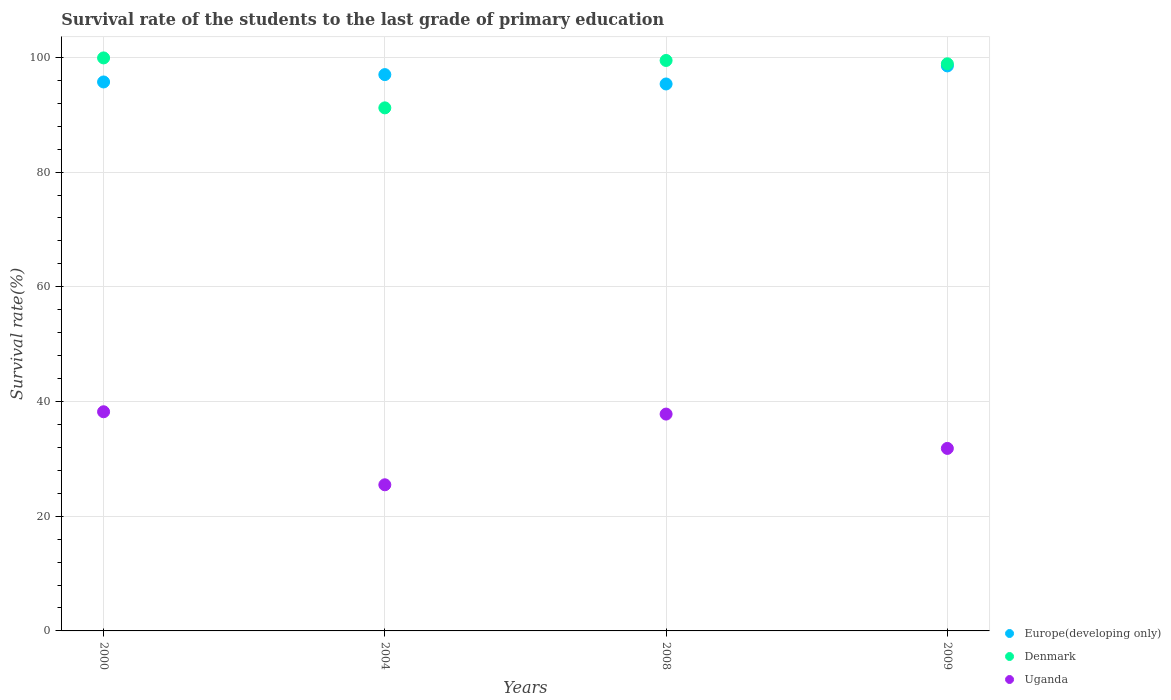How many different coloured dotlines are there?
Offer a terse response. 3. What is the survival rate of the students in Europe(developing only) in 2000?
Provide a short and direct response. 95.72. Across all years, what is the maximum survival rate of the students in Denmark?
Your answer should be very brief. 99.91. Across all years, what is the minimum survival rate of the students in Uganda?
Your answer should be very brief. 25.48. In which year was the survival rate of the students in Denmark maximum?
Offer a very short reply. 2000. In which year was the survival rate of the students in Europe(developing only) minimum?
Ensure brevity in your answer.  2008. What is the total survival rate of the students in Europe(developing only) in the graph?
Provide a succinct answer. 386.61. What is the difference between the survival rate of the students in Denmark in 2004 and that in 2009?
Your answer should be compact. -7.68. What is the difference between the survival rate of the students in Uganda in 2004 and the survival rate of the students in Denmark in 2000?
Make the answer very short. -74.43. What is the average survival rate of the students in Europe(developing only) per year?
Keep it short and to the point. 96.65. In the year 2004, what is the difference between the survival rate of the students in Europe(developing only) and survival rate of the students in Denmark?
Make the answer very short. 5.8. What is the ratio of the survival rate of the students in Uganda in 2004 to that in 2009?
Offer a very short reply. 0.8. Is the survival rate of the students in Uganda in 2004 less than that in 2009?
Provide a short and direct response. Yes. Is the difference between the survival rate of the students in Europe(developing only) in 2000 and 2009 greater than the difference between the survival rate of the students in Denmark in 2000 and 2009?
Your answer should be compact. No. What is the difference between the highest and the second highest survival rate of the students in Uganda?
Your response must be concise. 0.41. What is the difference between the highest and the lowest survival rate of the students in Denmark?
Your answer should be compact. 8.71. Is the sum of the survival rate of the students in Denmark in 2000 and 2008 greater than the maximum survival rate of the students in Uganda across all years?
Provide a succinct answer. Yes. Does the survival rate of the students in Europe(developing only) monotonically increase over the years?
Provide a short and direct response. No. Is the survival rate of the students in Europe(developing only) strictly less than the survival rate of the students in Denmark over the years?
Provide a succinct answer. No. How many years are there in the graph?
Your answer should be very brief. 4. Are the values on the major ticks of Y-axis written in scientific E-notation?
Your response must be concise. No. Does the graph contain any zero values?
Provide a succinct answer. No. Does the graph contain grids?
Offer a very short reply. Yes. How many legend labels are there?
Make the answer very short. 3. What is the title of the graph?
Give a very brief answer. Survival rate of the students to the last grade of primary education. What is the label or title of the X-axis?
Provide a succinct answer. Years. What is the label or title of the Y-axis?
Give a very brief answer. Survival rate(%). What is the Survival rate(%) in Europe(developing only) in 2000?
Your answer should be compact. 95.72. What is the Survival rate(%) in Denmark in 2000?
Keep it short and to the point. 99.91. What is the Survival rate(%) in Uganda in 2000?
Your response must be concise. 38.21. What is the Survival rate(%) of Europe(developing only) in 2004?
Provide a succinct answer. 97. What is the Survival rate(%) of Denmark in 2004?
Keep it short and to the point. 91.2. What is the Survival rate(%) in Uganda in 2004?
Ensure brevity in your answer.  25.48. What is the Survival rate(%) in Europe(developing only) in 2008?
Your answer should be compact. 95.37. What is the Survival rate(%) in Denmark in 2008?
Offer a very short reply. 99.47. What is the Survival rate(%) in Uganda in 2008?
Your answer should be very brief. 37.81. What is the Survival rate(%) of Europe(developing only) in 2009?
Offer a terse response. 98.52. What is the Survival rate(%) of Denmark in 2009?
Give a very brief answer. 98.89. What is the Survival rate(%) in Uganda in 2009?
Your response must be concise. 31.82. Across all years, what is the maximum Survival rate(%) of Europe(developing only)?
Offer a terse response. 98.52. Across all years, what is the maximum Survival rate(%) of Denmark?
Offer a terse response. 99.91. Across all years, what is the maximum Survival rate(%) in Uganda?
Your answer should be compact. 38.21. Across all years, what is the minimum Survival rate(%) of Europe(developing only)?
Provide a succinct answer. 95.37. Across all years, what is the minimum Survival rate(%) of Denmark?
Offer a very short reply. 91.2. Across all years, what is the minimum Survival rate(%) in Uganda?
Your answer should be very brief. 25.48. What is the total Survival rate(%) of Europe(developing only) in the graph?
Offer a very short reply. 386.61. What is the total Survival rate(%) in Denmark in the graph?
Your answer should be compact. 389.47. What is the total Survival rate(%) of Uganda in the graph?
Offer a very short reply. 133.33. What is the difference between the Survival rate(%) in Europe(developing only) in 2000 and that in 2004?
Give a very brief answer. -1.28. What is the difference between the Survival rate(%) of Denmark in 2000 and that in 2004?
Provide a short and direct response. 8.71. What is the difference between the Survival rate(%) in Uganda in 2000 and that in 2004?
Make the answer very short. 12.73. What is the difference between the Survival rate(%) of Europe(developing only) in 2000 and that in 2008?
Give a very brief answer. 0.35. What is the difference between the Survival rate(%) of Denmark in 2000 and that in 2008?
Your answer should be compact. 0.44. What is the difference between the Survival rate(%) in Uganda in 2000 and that in 2008?
Provide a succinct answer. 0.41. What is the difference between the Survival rate(%) of Europe(developing only) in 2000 and that in 2009?
Ensure brevity in your answer.  -2.8. What is the difference between the Survival rate(%) in Denmark in 2000 and that in 2009?
Give a very brief answer. 1.03. What is the difference between the Survival rate(%) in Uganda in 2000 and that in 2009?
Your answer should be very brief. 6.39. What is the difference between the Survival rate(%) in Europe(developing only) in 2004 and that in 2008?
Provide a short and direct response. 1.63. What is the difference between the Survival rate(%) in Denmark in 2004 and that in 2008?
Your answer should be compact. -8.26. What is the difference between the Survival rate(%) of Uganda in 2004 and that in 2008?
Provide a succinct answer. -12.33. What is the difference between the Survival rate(%) in Europe(developing only) in 2004 and that in 2009?
Your response must be concise. -1.52. What is the difference between the Survival rate(%) in Denmark in 2004 and that in 2009?
Your answer should be very brief. -7.68. What is the difference between the Survival rate(%) in Uganda in 2004 and that in 2009?
Ensure brevity in your answer.  -6.34. What is the difference between the Survival rate(%) in Europe(developing only) in 2008 and that in 2009?
Keep it short and to the point. -3.15. What is the difference between the Survival rate(%) of Denmark in 2008 and that in 2009?
Provide a succinct answer. 0.58. What is the difference between the Survival rate(%) of Uganda in 2008 and that in 2009?
Offer a terse response. 5.98. What is the difference between the Survival rate(%) in Europe(developing only) in 2000 and the Survival rate(%) in Denmark in 2004?
Make the answer very short. 4.52. What is the difference between the Survival rate(%) of Europe(developing only) in 2000 and the Survival rate(%) of Uganda in 2004?
Keep it short and to the point. 70.24. What is the difference between the Survival rate(%) of Denmark in 2000 and the Survival rate(%) of Uganda in 2004?
Offer a very short reply. 74.43. What is the difference between the Survival rate(%) of Europe(developing only) in 2000 and the Survival rate(%) of Denmark in 2008?
Offer a very short reply. -3.75. What is the difference between the Survival rate(%) of Europe(developing only) in 2000 and the Survival rate(%) of Uganda in 2008?
Offer a very short reply. 57.91. What is the difference between the Survival rate(%) of Denmark in 2000 and the Survival rate(%) of Uganda in 2008?
Your answer should be compact. 62.1. What is the difference between the Survival rate(%) of Europe(developing only) in 2000 and the Survival rate(%) of Denmark in 2009?
Keep it short and to the point. -3.17. What is the difference between the Survival rate(%) of Europe(developing only) in 2000 and the Survival rate(%) of Uganda in 2009?
Your response must be concise. 63.9. What is the difference between the Survival rate(%) in Denmark in 2000 and the Survival rate(%) in Uganda in 2009?
Give a very brief answer. 68.09. What is the difference between the Survival rate(%) in Europe(developing only) in 2004 and the Survival rate(%) in Denmark in 2008?
Provide a succinct answer. -2.47. What is the difference between the Survival rate(%) in Europe(developing only) in 2004 and the Survival rate(%) in Uganda in 2008?
Make the answer very short. 59.19. What is the difference between the Survival rate(%) of Denmark in 2004 and the Survival rate(%) of Uganda in 2008?
Provide a succinct answer. 53.39. What is the difference between the Survival rate(%) in Europe(developing only) in 2004 and the Survival rate(%) in Denmark in 2009?
Your response must be concise. -1.88. What is the difference between the Survival rate(%) of Europe(developing only) in 2004 and the Survival rate(%) of Uganda in 2009?
Provide a succinct answer. 65.18. What is the difference between the Survival rate(%) in Denmark in 2004 and the Survival rate(%) in Uganda in 2009?
Offer a very short reply. 59.38. What is the difference between the Survival rate(%) in Europe(developing only) in 2008 and the Survival rate(%) in Denmark in 2009?
Keep it short and to the point. -3.52. What is the difference between the Survival rate(%) in Europe(developing only) in 2008 and the Survival rate(%) in Uganda in 2009?
Your answer should be very brief. 63.54. What is the difference between the Survival rate(%) in Denmark in 2008 and the Survival rate(%) in Uganda in 2009?
Give a very brief answer. 67.64. What is the average Survival rate(%) of Europe(developing only) per year?
Your answer should be very brief. 96.65. What is the average Survival rate(%) in Denmark per year?
Make the answer very short. 97.37. What is the average Survival rate(%) in Uganda per year?
Your response must be concise. 33.33. In the year 2000, what is the difference between the Survival rate(%) in Europe(developing only) and Survival rate(%) in Denmark?
Ensure brevity in your answer.  -4.19. In the year 2000, what is the difference between the Survival rate(%) of Europe(developing only) and Survival rate(%) of Uganda?
Your answer should be compact. 57.51. In the year 2000, what is the difference between the Survival rate(%) of Denmark and Survival rate(%) of Uganda?
Provide a short and direct response. 61.7. In the year 2004, what is the difference between the Survival rate(%) of Europe(developing only) and Survival rate(%) of Denmark?
Provide a succinct answer. 5.8. In the year 2004, what is the difference between the Survival rate(%) in Europe(developing only) and Survival rate(%) in Uganda?
Provide a succinct answer. 71.52. In the year 2004, what is the difference between the Survival rate(%) in Denmark and Survival rate(%) in Uganda?
Your answer should be compact. 65.72. In the year 2008, what is the difference between the Survival rate(%) of Europe(developing only) and Survival rate(%) of Denmark?
Your response must be concise. -4.1. In the year 2008, what is the difference between the Survival rate(%) in Europe(developing only) and Survival rate(%) in Uganda?
Give a very brief answer. 57.56. In the year 2008, what is the difference between the Survival rate(%) of Denmark and Survival rate(%) of Uganda?
Provide a short and direct response. 61.66. In the year 2009, what is the difference between the Survival rate(%) of Europe(developing only) and Survival rate(%) of Denmark?
Your response must be concise. -0.37. In the year 2009, what is the difference between the Survival rate(%) of Europe(developing only) and Survival rate(%) of Uganda?
Your answer should be very brief. 66.7. In the year 2009, what is the difference between the Survival rate(%) of Denmark and Survival rate(%) of Uganda?
Make the answer very short. 67.06. What is the ratio of the Survival rate(%) in Europe(developing only) in 2000 to that in 2004?
Make the answer very short. 0.99. What is the ratio of the Survival rate(%) of Denmark in 2000 to that in 2004?
Make the answer very short. 1.1. What is the ratio of the Survival rate(%) in Uganda in 2000 to that in 2004?
Give a very brief answer. 1.5. What is the ratio of the Survival rate(%) of Europe(developing only) in 2000 to that in 2008?
Your answer should be very brief. 1. What is the ratio of the Survival rate(%) in Denmark in 2000 to that in 2008?
Keep it short and to the point. 1. What is the ratio of the Survival rate(%) in Uganda in 2000 to that in 2008?
Provide a short and direct response. 1.01. What is the ratio of the Survival rate(%) of Europe(developing only) in 2000 to that in 2009?
Make the answer very short. 0.97. What is the ratio of the Survival rate(%) in Denmark in 2000 to that in 2009?
Keep it short and to the point. 1.01. What is the ratio of the Survival rate(%) in Uganda in 2000 to that in 2009?
Keep it short and to the point. 1.2. What is the ratio of the Survival rate(%) of Europe(developing only) in 2004 to that in 2008?
Your response must be concise. 1.02. What is the ratio of the Survival rate(%) of Denmark in 2004 to that in 2008?
Offer a very short reply. 0.92. What is the ratio of the Survival rate(%) of Uganda in 2004 to that in 2008?
Your response must be concise. 0.67. What is the ratio of the Survival rate(%) of Europe(developing only) in 2004 to that in 2009?
Your response must be concise. 0.98. What is the ratio of the Survival rate(%) in Denmark in 2004 to that in 2009?
Offer a terse response. 0.92. What is the ratio of the Survival rate(%) of Uganda in 2004 to that in 2009?
Your answer should be very brief. 0.8. What is the ratio of the Survival rate(%) of Europe(developing only) in 2008 to that in 2009?
Offer a terse response. 0.97. What is the ratio of the Survival rate(%) of Denmark in 2008 to that in 2009?
Offer a very short reply. 1.01. What is the ratio of the Survival rate(%) in Uganda in 2008 to that in 2009?
Make the answer very short. 1.19. What is the difference between the highest and the second highest Survival rate(%) in Europe(developing only)?
Give a very brief answer. 1.52. What is the difference between the highest and the second highest Survival rate(%) in Denmark?
Offer a terse response. 0.44. What is the difference between the highest and the second highest Survival rate(%) in Uganda?
Make the answer very short. 0.41. What is the difference between the highest and the lowest Survival rate(%) in Europe(developing only)?
Ensure brevity in your answer.  3.15. What is the difference between the highest and the lowest Survival rate(%) of Denmark?
Offer a terse response. 8.71. What is the difference between the highest and the lowest Survival rate(%) of Uganda?
Your response must be concise. 12.73. 